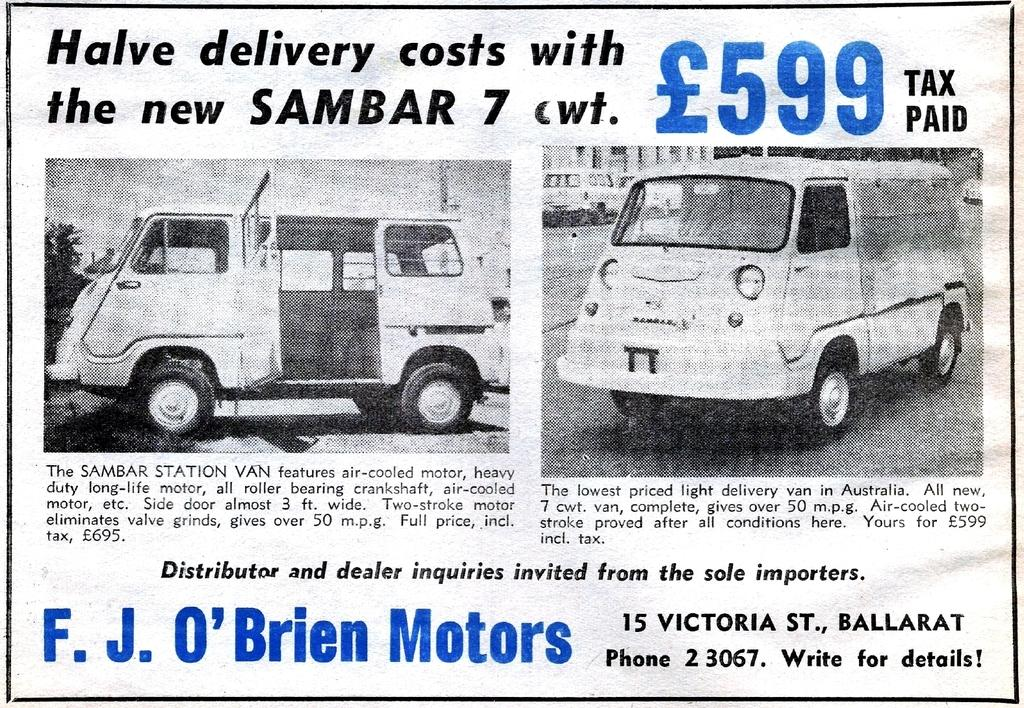What type of images can be seen in the picture? There are pictures of vehicles in the image. What else is present in the image besides the vehicle pictures? There is text written on paper in the image. Can you see a snake slithering across the text in the image? No, there is no snake present in the image. 